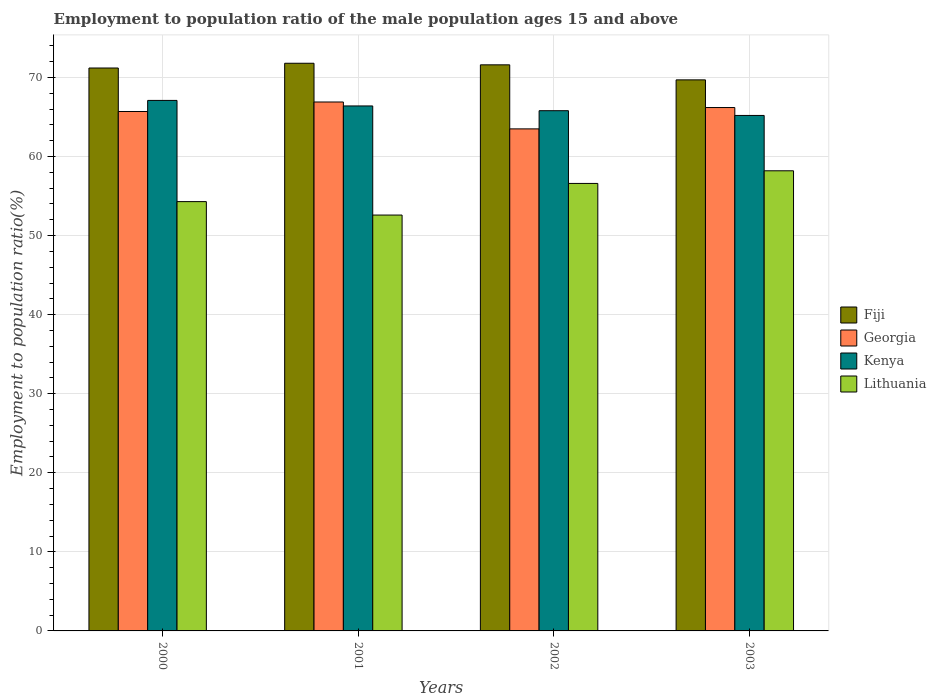How many different coloured bars are there?
Offer a very short reply. 4. How many bars are there on the 4th tick from the left?
Provide a succinct answer. 4. How many bars are there on the 1st tick from the right?
Provide a succinct answer. 4. In how many cases, is the number of bars for a given year not equal to the number of legend labels?
Give a very brief answer. 0. What is the employment to population ratio in Georgia in 2003?
Offer a very short reply. 66.2. Across all years, what is the maximum employment to population ratio in Fiji?
Give a very brief answer. 71.8. Across all years, what is the minimum employment to population ratio in Fiji?
Ensure brevity in your answer.  69.7. In which year was the employment to population ratio in Kenya minimum?
Make the answer very short. 2003. What is the total employment to population ratio in Lithuania in the graph?
Make the answer very short. 221.7. What is the difference between the employment to population ratio in Fiji in 2001 and that in 2002?
Your answer should be very brief. 0.2. What is the difference between the employment to population ratio in Georgia in 2001 and the employment to population ratio in Fiji in 2002?
Ensure brevity in your answer.  -4.7. What is the average employment to population ratio in Lithuania per year?
Give a very brief answer. 55.42. In the year 2003, what is the difference between the employment to population ratio in Kenya and employment to population ratio in Lithuania?
Your answer should be very brief. 7. In how many years, is the employment to population ratio in Kenya greater than 46 %?
Your response must be concise. 4. What is the ratio of the employment to population ratio in Lithuania in 2000 to that in 2002?
Offer a very short reply. 0.96. Is the employment to population ratio in Kenya in 2001 less than that in 2003?
Your response must be concise. No. Is the difference between the employment to population ratio in Kenya in 2000 and 2003 greater than the difference between the employment to population ratio in Lithuania in 2000 and 2003?
Make the answer very short. Yes. What is the difference between the highest and the second highest employment to population ratio in Fiji?
Provide a short and direct response. 0.2. What is the difference between the highest and the lowest employment to population ratio in Kenya?
Your answer should be compact. 1.9. Is it the case that in every year, the sum of the employment to population ratio in Georgia and employment to population ratio in Kenya is greater than the sum of employment to population ratio in Lithuania and employment to population ratio in Fiji?
Provide a succinct answer. Yes. What does the 3rd bar from the left in 2001 represents?
Keep it short and to the point. Kenya. What does the 1st bar from the right in 2000 represents?
Ensure brevity in your answer.  Lithuania. How many bars are there?
Provide a succinct answer. 16. Are all the bars in the graph horizontal?
Your answer should be compact. No. Are the values on the major ticks of Y-axis written in scientific E-notation?
Make the answer very short. No. Does the graph contain any zero values?
Provide a short and direct response. No. Does the graph contain grids?
Provide a short and direct response. Yes. Where does the legend appear in the graph?
Provide a short and direct response. Center right. How are the legend labels stacked?
Offer a terse response. Vertical. What is the title of the graph?
Your answer should be compact. Employment to population ratio of the male population ages 15 and above. What is the label or title of the Y-axis?
Provide a short and direct response. Employment to population ratio(%). What is the Employment to population ratio(%) in Fiji in 2000?
Provide a succinct answer. 71.2. What is the Employment to population ratio(%) in Georgia in 2000?
Your answer should be very brief. 65.7. What is the Employment to population ratio(%) of Kenya in 2000?
Provide a succinct answer. 67.1. What is the Employment to population ratio(%) of Lithuania in 2000?
Provide a short and direct response. 54.3. What is the Employment to population ratio(%) of Fiji in 2001?
Offer a very short reply. 71.8. What is the Employment to population ratio(%) in Georgia in 2001?
Keep it short and to the point. 66.9. What is the Employment to population ratio(%) in Kenya in 2001?
Ensure brevity in your answer.  66.4. What is the Employment to population ratio(%) of Lithuania in 2001?
Offer a terse response. 52.6. What is the Employment to population ratio(%) of Fiji in 2002?
Your answer should be compact. 71.6. What is the Employment to population ratio(%) in Georgia in 2002?
Your answer should be very brief. 63.5. What is the Employment to population ratio(%) of Kenya in 2002?
Provide a short and direct response. 65.8. What is the Employment to population ratio(%) in Lithuania in 2002?
Provide a succinct answer. 56.6. What is the Employment to population ratio(%) of Fiji in 2003?
Provide a succinct answer. 69.7. What is the Employment to population ratio(%) in Georgia in 2003?
Ensure brevity in your answer.  66.2. What is the Employment to population ratio(%) of Kenya in 2003?
Your response must be concise. 65.2. What is the Employment to population ratio(%) in Lithuania in 2003?
Make the answer very short. 58.2. Across all years, what is the maximum Employment to population ratio(%) in Fiji?
Your answer should be very brief. 71.8. Across all years, what is the maximum Employment to population ratio(%) in Georgia?
Give a very brief answer. 66.9. Across all years, what is the maximum Employment to population ratio(%) in Kenya?
Give a very brief answer. 67.1. Across all years, what is the maximum Employment to population ratio(%) of Lithuania?
Ensure brevity in your answer.  58.2. Across all years, what is the minimum Employment to population ratio(%) in Fiji?
Offer a very short reply. 69.7. Across all years, what is the minimum Employment to population ratio(%) of Georgia?
Keep it short and to the point. 63.5. Across all years, what is the minimum Employment to population ratio(%) in Kenya?
Provide a short and direct response. 65.2. Across all years, what is the minimum Employment to population ratio(%) in Lithuania?
Your answer should be compact. 52.6. What is the total Employment to population ratio(%) of Fiji in the graph?
Provide a short and direct response. 284.3. What is the total Employment to population ratio(%) of Georgia in the graph?
Offer a terse response. 262.3. What is the total Employment to population ratio(%) of Kenya in the graph?
Make the answer very short. 264.5. What is the total Employment to population ratio(%) in Lithuania in the graph?
Offer a terse response. 221.7. What is the difference between the Employment to population ratio(%) in Fiji in 2000 and that in 2001?
Offer a terse response. -0.6. What is the difference between the Employment to population ratio(%) in Fiji in 2000 and that in 2002?
Offer a terse response. -0.4. What is the difference between the Employment to population ratio(%) in Georgia in 2000 and that in 2002?
Your answer should be very brief. 2.2. What is the difference between the Employment to population ratio(%) in Lithuania in 2000 and that in 2002?
Offer a terse response. -2.3. What is the difference between the Employment to population ratio(%) in Fiji in 2000 and that in 2003?
Your answer should be very brief. 1.5. What is the difference between the Employment to population ratio(%) of Georgia in 2000 and that in 2003?
Give a very brief answer. -0.5. What is the difference between the Employment to population ratio(%) of Kenya in 2001 and that in 2002?
Provide a short and direct response. 0.6. What is the difference between the Employment to population ratio(%) of Fiji in 2001 and that in 2003?
Give a very brief answer. 2.1. What is the difference between the Employment to population ratio(%) in Lithuania in 2001 and that in 2003?
Give a very brief answer. -5.6. What is the difference between the Employment to population ratio(%) of Fiji in 2000 and the Employment to population ratio(%) of Georgia in 2001?
Provide a short and direct response. 4.3. What is the difference between the Employment to population ratio(%) of Fiji in 2000 and the Employment to population ratio(%) of Georgia in 2002?
Offer a terse response. 7.7. What is the difference between the Employment to population ratio(%) in Fiji in 2000 and the Employment to population ratio(%) in Kenya in 2002?
Ensure brevity in your answer.  5.4. What is the difference between the Employment to population ratio(%) of Georgia in 2000 and the Employment to population ratio(%) of Lithuania in 2002?
Your response must be concise. 9.1. What is the difference between the Employment to population ratio(%) in Kenya in 2000 and the Employment to population ratio(%) in Lithuania in 2002?
Give a very brief answer. 10.5. What is the difference between the Employment to population ratio(%) in Fiji in 2000 and the Employment to population ratio(%) in Georgia in 2003?
Give a very brief answer. 5. What is the difference between the Employment to population ratio(%) in Fiji in 2000 and the Employment to population ratio(%) in Kenya in 2003?
Give a very brief answer. 6. What is the difference between the Employment to population ratio(%) in Fiji in 2000 and the Employment to population ratio(%) in Lithuania in 2003?
Provide a short and direct response. 13. What is the difference between the Employment to population ratio(%) of Georgia in 2000 and the Employment to population ratio(%) of Lithuania in 2003?
Keep it short and to the point. 7.5. What is the difference between the Employment to population ratio(%) of Kenya in 2000 and the Employment to population ratio(%) of Lithuania in 2003?
Your answer should be very brief. 8.9. What is the difference between the Employment to population ratio(%) of Fiji in 2001 and the Employment to population ratio(%) of Georgia in 2002?
Provide a succinct answer. 8.3. What is the difference between the Employment to population ratio(%) in Fiji in 2001 and the Employment to population ratio(%) in Kenya in 2002?
Your response must be concise. 6. What is the difference between the Employment to population ratio(%) of Georgia in 2001 and the Employment to population ratio(%) of Kenya in 2002?
Your response must be concise. 1.1. What is the difference between the Employment to population ratio(%) of Georgia in 2001 and the Employment to population ratio(%) of Lithuania in 2002?
Keep it short and to the point. 10.3. What is the difference between the Employment to population ratio(%) in Fiji in 2001 and the Employment to population ratio(%) in Kenya in 2003?
Give a very brief answer. 6.6. What is the difference between the Employment to population ratio(%) in Georgia in 2001 and the Employment to population ratio(%) in Lithuania in 2003?
Give a very brief answer. 8.7. What is the difference between the Employment to population ratio(%) of Georgia in 2002 and the Employment to population ratio(%) of Lithuania in 2003?
Make the answer very short. 5.3. What is the difference between the Employment to population ratio(%) of Kenya in 2002 and the Employment to population ratio(%) of Lithuania in 2003?
Provide a short and direct response. 7.6. What is the average Employment to population ratio(%) of Fiji per year?
Your response must be concise. 71.08. What is the average Employment to population ratio(%) of Georgia per year?
Your answer should be compact. 65.58. What is the average Employment to population ratio(%) of Kenya per year?
Your response must be concise. 66.12. What is the average Employment to population ratio(%) of Lithuania per year?
Provide a succinct answer. 55.42. In the year 2000, what is the difference between the Employment to population ratio(%) of Fiji and Employment to population ratio(%) of Georgia?
Give a very brief answer. 5.5. In the year 2000, what is the difference between the Employment to population ratio(%) of Georgia and Employment to population ratio(%) of Kenya?
Ensure brevity in your answer.  -1.4. In the year 2000, what is the difference between the Employment to population ratio(%) in Georgia and Employment to population ratio(%) in Lithuania?
Your answer should be compact. 11.4. In the year 2000, what is the difference between the Employment to population ratio(%) in Kenya and Employment to population ratio(%) in Lithuania?
Your response must be concise. 12.8. In the year 2001, what is the difference between the Employment to population ratio(%) in Fiji and Employment to population ratio(%) in Kenya?
Offer a terse response. 5.4. In the year 2001, what is the difference between the Employment to population ratio(%) of Fiji and Employment to population ratio(%) of Lithuania?
Make the answer very short. 19.2. In the year 2002, what is the difference between the Employment to population ratio(%) in Fiji and Employment to population ratio(%) in Georgia?
Provide a succinct answer. 8.1. In the year 2002, what is the difference between the Employment to population ratio(%) in Fiji and Employment to population ratio(%) in Kenya?
Provide a succinct answer. 5.8. In the year 2002, what is the difference between the Employment to population ratio(%) of Fiji and Employment to population ratio(%) of Lithuania?
Your answer should be compact. 15. In the year 2003, what is the difference between the Employment to population ratio(%) in Fiji and Employment to population ratio(%) in Kenya?
Your answer should be very brief. 4.5. In the year 2003, what is the difference between the Employment to population ratio(%) in Georgia and Employment to population ratio(%) in Kenya?
Keep it short and to the point. 1. In the year 2003, what is the difference between the Employment to population ratio(%) in Georgia and Employment to population ratio(%) in Lithuania?
Ensure brevity in your answer.  8. What is the ratio of the Employment to population ratio(%) of Georgia in 2000 to that in 2001?
Make the answer very short. 0.98. What is the ratio of the Employment to population ratio(%) in Kenya in 2000 to that in 2001?
Provide a succinct answer. 1.01. What is the ratio of the Employment to population ratio(%) in Lithuania in 2000 to that in 2001?
Provide a succinct answer. 1.03. What is the ratio of the Employment to population ratio(%) of Georgia in 2000 to that in 2002?
Your response must be concise. 1.03. What is the ratio of the Employment to population ratio(%) in Kenya in 2000 to that in 2002?
Keep it short and to the point. 1.02. What is the ratio of the Employment to population ratio(%) in Lithuania in 2000 to that in 2002?
Offer a very short reply. 0.96. What is the ratio of the Employment to population ratio(%) of Fiji in 2000 to that in 2003?
Ensure brevity in your answer.  1.02. What is the ratio of the Employment to population ratio(%) of Georgia in 2000 to that in 2003?
Your answer should be compact. 0.99. What is the ratio of the Employment to population ratio(%) in Kenya in 2000 to that in 2003?
Ensure brevity in your answer.  1.03. What is the ratio of the Employment to population ratio(%) of Lithuania in 2000 to that in 2003?
Give a very brief answer. 0.93. What is the ratio of the Employment to population ratio(%) in Georgia in 2001 to that in 2002?
Ensure brevity in your answer.  1.05. What is the ratio of the Employment to population ratio(%) of Kenya in 2001 to that in 2002?
Make the answer very short. 1.01. What is the ratio of the Employment to population ratio(%) of Lithuania in 2001 to that in 2002?
Your response must be concise. 0.93. What is the ratio of the Employment to population ratio(%) in Fiji in 2001 to that in 2003?
Make the answer very short. 1.03. What is the ratio of the Employment to population ratio(%) of Georgia in 2001 to that in 2003?
Give a very brief answer. 1.01. What is the ratio of the Employment to population ratio(%) in Kenya in 2001 to that in 2003?
Make the answer very short. 1.02. What is the ratio of the Employment to population ratio(%) of Lithuania in 2001 to that in 2003?
Ensure brevity in your answer.  0.9. What is the ratio of the Employment to population ratio(%) of Fiji in 2002 to that in 2003?
Give a very brief answer. 1.03. What is the ratio of the Employment to population ratio(%) of Georgia in 2002 to that in 2003?
Your answer should be very brief. 0.96. What is the ratio of the Employment to population ratio(%) of Kenya in 2002 to that in 2003?
Your answer should be compact. 1.01. What is the ratio of the Employment to population ratio(%) in Lithuania in 2002 to that in 2003?
Ensure brevity in your answer.  0.97. What is the difference between the highest and the second highest Employment to population ratio(%) of Fiji?
Provide a succinct answer. 0.2. What is the difference between the highest and the second highest Employment to population ratio(%) in Lithuania?
Offer a very short reply. 1.6. What is the difference between the highest and the lowest Employment to population ratio(%) in Fiji?
Keep it short and to the point. 2.1. What is the difference between the highest and the lowest Employment to population ratio(%) of Lithuania?
Ensure brevity in your answer.  5.6. 